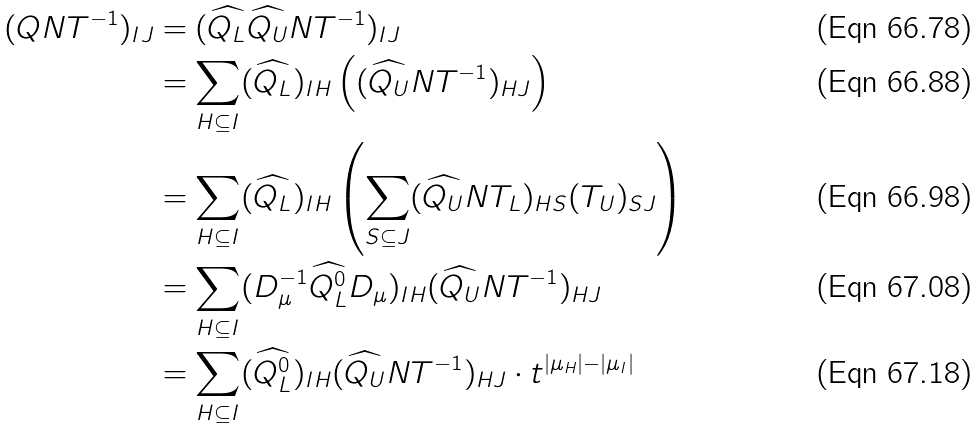<formula> <loc_0><loc_0><loc_500><loc_500>( Q N T ^ { - 1 } ) _ { I J } & = ( \widehat { Q _ { L } } \widehat { Q _ { U } } N T ^ { - 1 } ) _ { I J } \\ & = \sum _ { H \subseteq I } ( \widehat { Q _ { L } } ) _ { I H } \left ( ( \widehat { Q _ { U } } N T ^ { - 1 } ) _ { H J } \right ) \\ & = \sum _ { H \subseteq I } ( \widehat { Q _ { L } } ) _ { I H } \left ( \sum _ { S \subseteq J } ( \widehat { Q _ { U } } N T _ { L } ) _ { H S } ( T _ { U } ) _ { S J } \right ) \\ & = \sum _ { H \subseteq I } ( D _ { \mu } ^ { - 1 } \widehat { Q _ { L } ^ { 0 } } D _ { \mu } ) _ { I H } ( \widehat { Q _ { U } } N T ^ { - 1 } ) _ { H J } \\ & = \sum _ { H \subseteq I } ( \widehat { Q _ { L } ^ { 0 } } ) _ { I H } ( \widehat { Q _ { U } } N T ^ { - 1 } ) _ { H J } \cdot t ^ { | \mu _ { H } | - | \mu _ { I } | }</formula> 